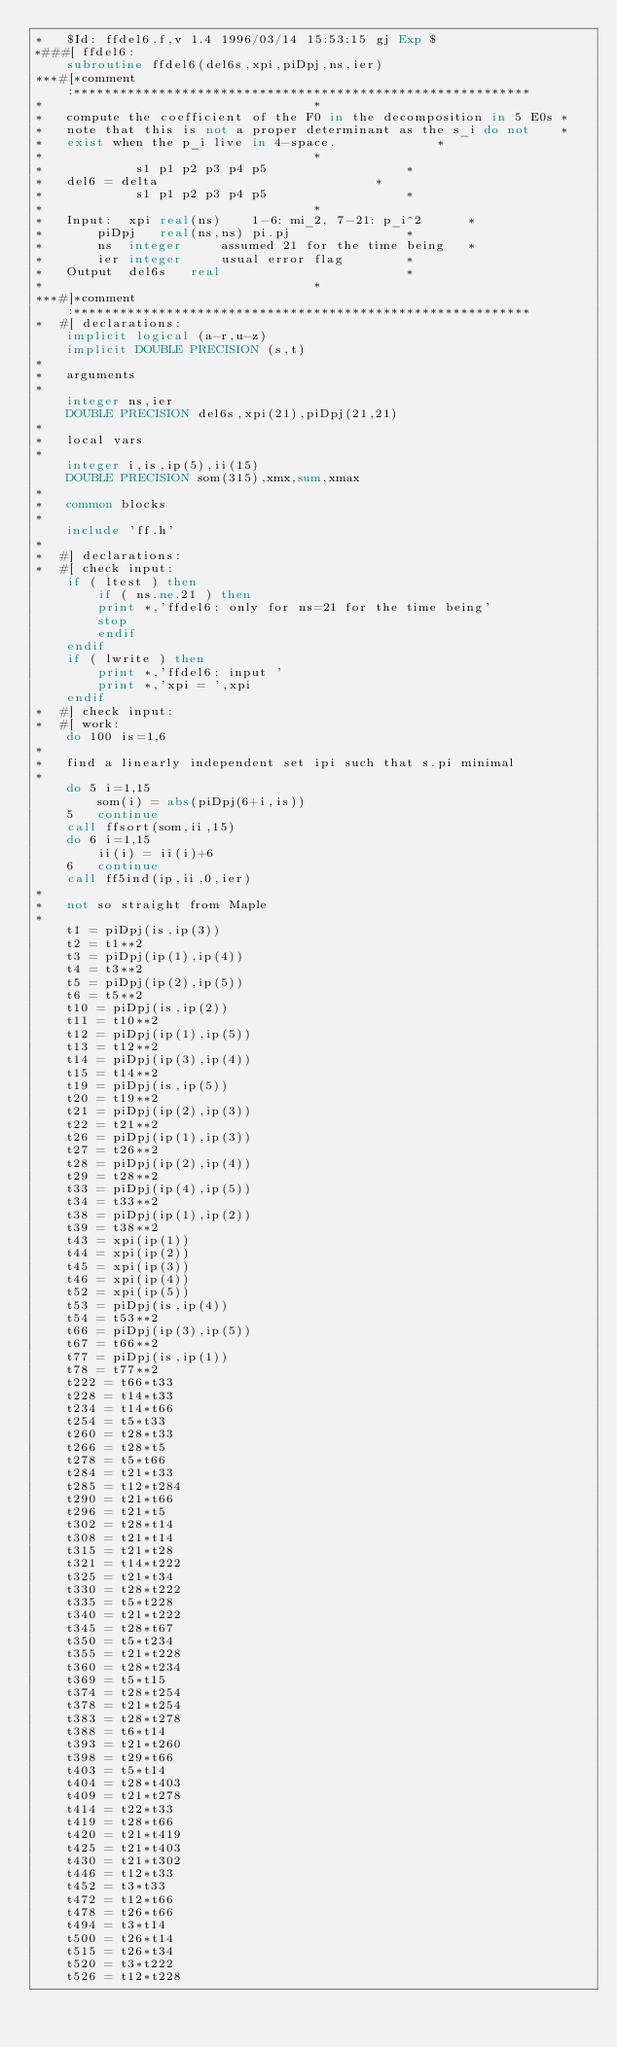<code> <loc_0><loc_0><loc_500><loc_500><_FORTRAN_>*	$Id: ffdel6.f,v 1.4 1996/03/14 15:53:15 gj Exp $
*###[ ffdel6:
	subroutine ffdel6(del6s,xpi,piDpj,ns,ier)
***#[*comment:***********************************************************
*									*
*	compute the coefficient of the F0 in the decomposition in 5 E0s	*
*	note that this is not a proper determinant as the s_i do not	*
*	exist when the p_i live in 4-space.				*
*									*
*		     s1 p1 p2 p3 p4 p5					*
*	del6 = delta							*
*		     s1 p1 p2 p3 p4 p5					*
*									*
*	Input:	xpi	real(ns)	1-6: mi_2, 7-21: p_i^2		*
*		piDpj	real(ns,ns)	pi.pj				*
*		ns	integer		assumed 21 for the time being	*
*		ier	integer		usual error flag		*
*	Output	del6s	real						*
*									*
***#]*comment:***********************************************************
*  #[ declarations:
	implicit logical (a-r,u-z)
	implicit DOUBLE PRECISION (s,t)
*
*	arguments
*
	integer ns,ier
	DOUBLE PRECISION del6s,xpi(21),piDpj(21,21)
*
*	local vars
*
	integer i,is,ip(5),ii(15)
	DOUBLE PRECISION som(315),xmx,sum,xmax
*
*	common blocks
*
	include 'ff.h'
*
*  #] declarations:
*  #[ check input:
	if ( ltest ) then
	    if ( ns.ne.21 ) then
		print *,'ffdel6: only for ns=21 for the time being'
		stop
	    endif
	endif
	if ( lwrite ) then
	    print *,'ffdel6: input '
	    print *,'xpi = ',xpi
	endif
*  #] check input:
*  #[ work:
	do 100 is=1,6
*
*	find a linearly independent set ipi such that s.pi minimal
*
	do 5 i=1,15
	    som(i) = abs(piDpj(6+i,is))
    5	continue
	call ffsort(som,ii,15)
	do 6 i=1,15
	    ii(i) = ii(i)+6
    6	continue
	call ff5ind(ip,ii,0,ier)
*
*	not so straight from Maple
*
	t1 = piDpj(is,ip(3))
	t2 = t1**2
	t3 = piDpj(ip(1),ip(4))
	t4 = t3**2
	t5 = piDpj(ip(2),ip(5))
	t6 = t5**2
	t10 = piDpj(is,ip(2))
	t11 = t10**2
	t12 = piDpj(ip(1),ip(5))
	t13 = t12**2
	t14 = piDpj(ip(3),ip(4))
	t15 = t14**2
	t19 = piDpj(is,ip(5))
	t20 = t19**2
	t21 = piDpj(ip(2),ip(3))
	t22 = t21**2
	t26 = piDpj(ip(1),ip(3))
	t27 = t26**2
	t28 = piDpj(ip(2),ip(4))
	t29 = t28**2
	t33 = piDpj(ip(4),ip(5))
	t34 = t33**2
	t38 = piDpj(ip(1),ip(2))
	t39 = t38**2
	t43 = xpi(ip(1))
	t44 = xpi(ip(2))
	t45 = xpi(ip(3))
	t46 = xpi(ip(4))
	t52 = xpi(ip(5))
	t53 = piDpj(is,ip(4))
	t54 = t53**2
	t66 = piDpj(ip(3),ip(5))
	t67 = t66**2
	t77 = piDpj(is,ip(1))
	t78 = t77**2
	t222 = t66*t33
	t228 = t14*t33
	t234 = t14*t66
	t254 = t5*t33
	t260 = t28*t33
	t266 = t28*t5
	t278 = t5*t66
	t284 = t21*t33
	t285 = t12*t284
	t290 = t21*t66
	t296 = t21*t5
	t302 = t28*t14
	t308 = t21*t14
	t315 = t21*t28
	t321 = t14*t222
	t325 = t21*t34
	t330 = t28*t222
	t335 = t5*t228
	t340 = t21*t222
	t345 = t28*t67
	t350 = t5*t234
	t355 = t21*t228
	t360 = t28*t234
	t369 = t5*t15
	t374 = t28*t254
	t378 = t21*t254
	t383 = t28*t278
	t388 = t6*t14
	t393 = t21*t260
	t398 = t29*t66
	t403 = t5*t14
	t404 = t28*t403
	t409 = t21*t278
	t414 = t22*t33
	t419 = t28*t66
	t420 = t21*t419
	t425 = t21*t403
	t430 = t21*t302
	t446 = t12*t33
	t452 = t3*t33
	t472 = t12*t66
	t478 = t26*t66
	t494 = t3*t14
	t500 = t26*t14
	t515 = t26*t34
	t520 = t3*t222
	t526 = t12*t228</code> 